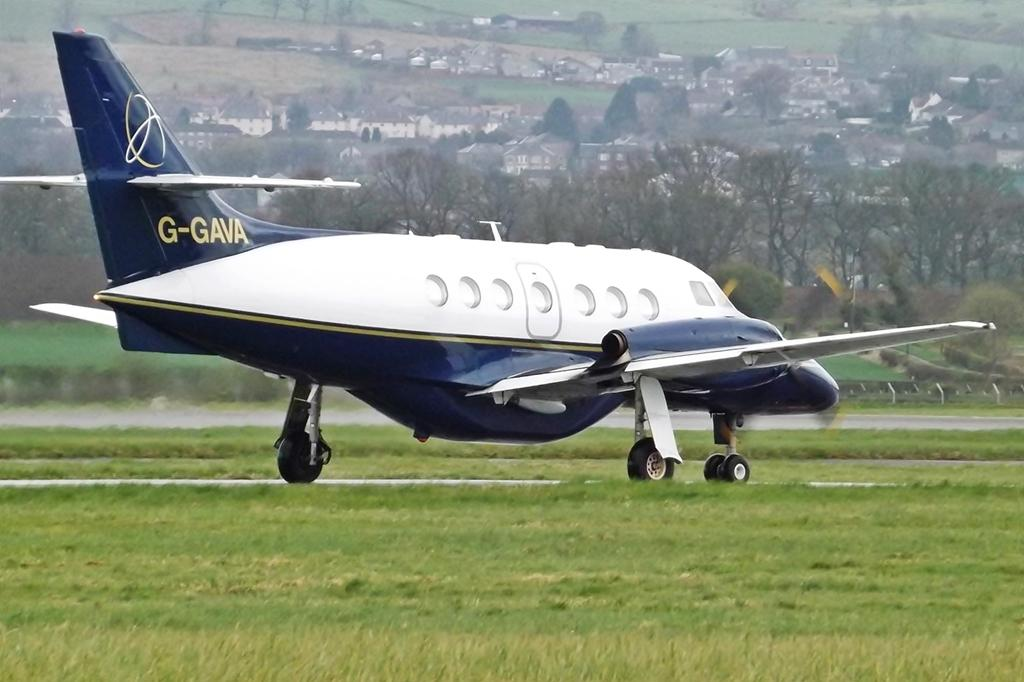<image>
Describe the image concisely. A small twin jet engine blue and white plane with G-GAVA letters on the tail. 